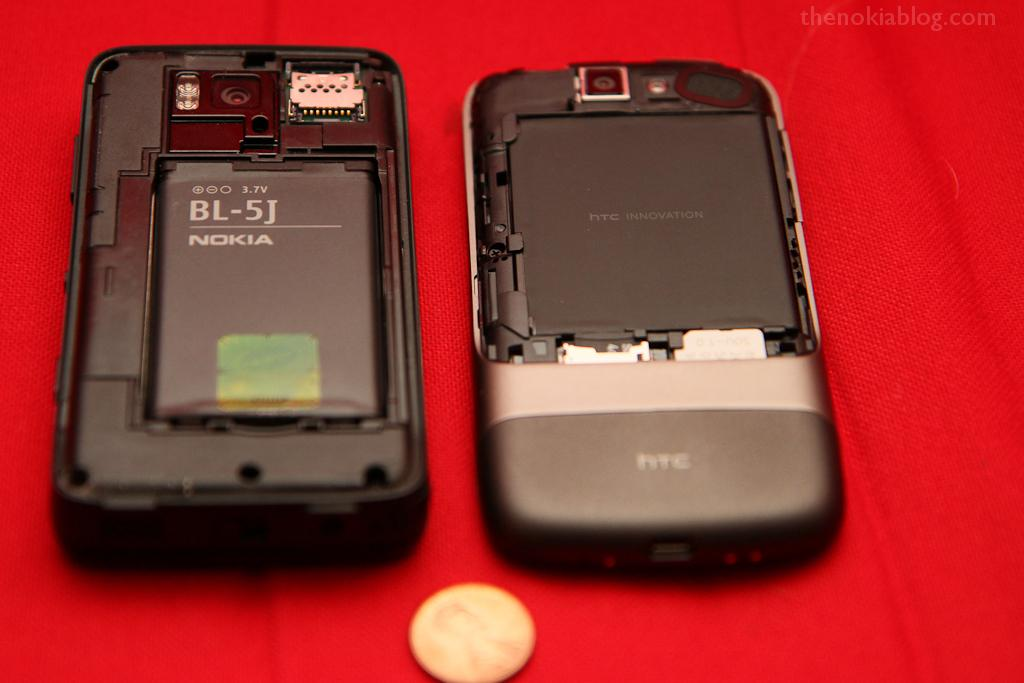<image>
Give a short and clear explanation of the subsequent image. The back of a cell phone has been removed to display a Nokia battery. 